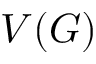Convert formula to latex. <formula><loc_0><loc_0><loc_500><loc_500>V ( G )</formula> 